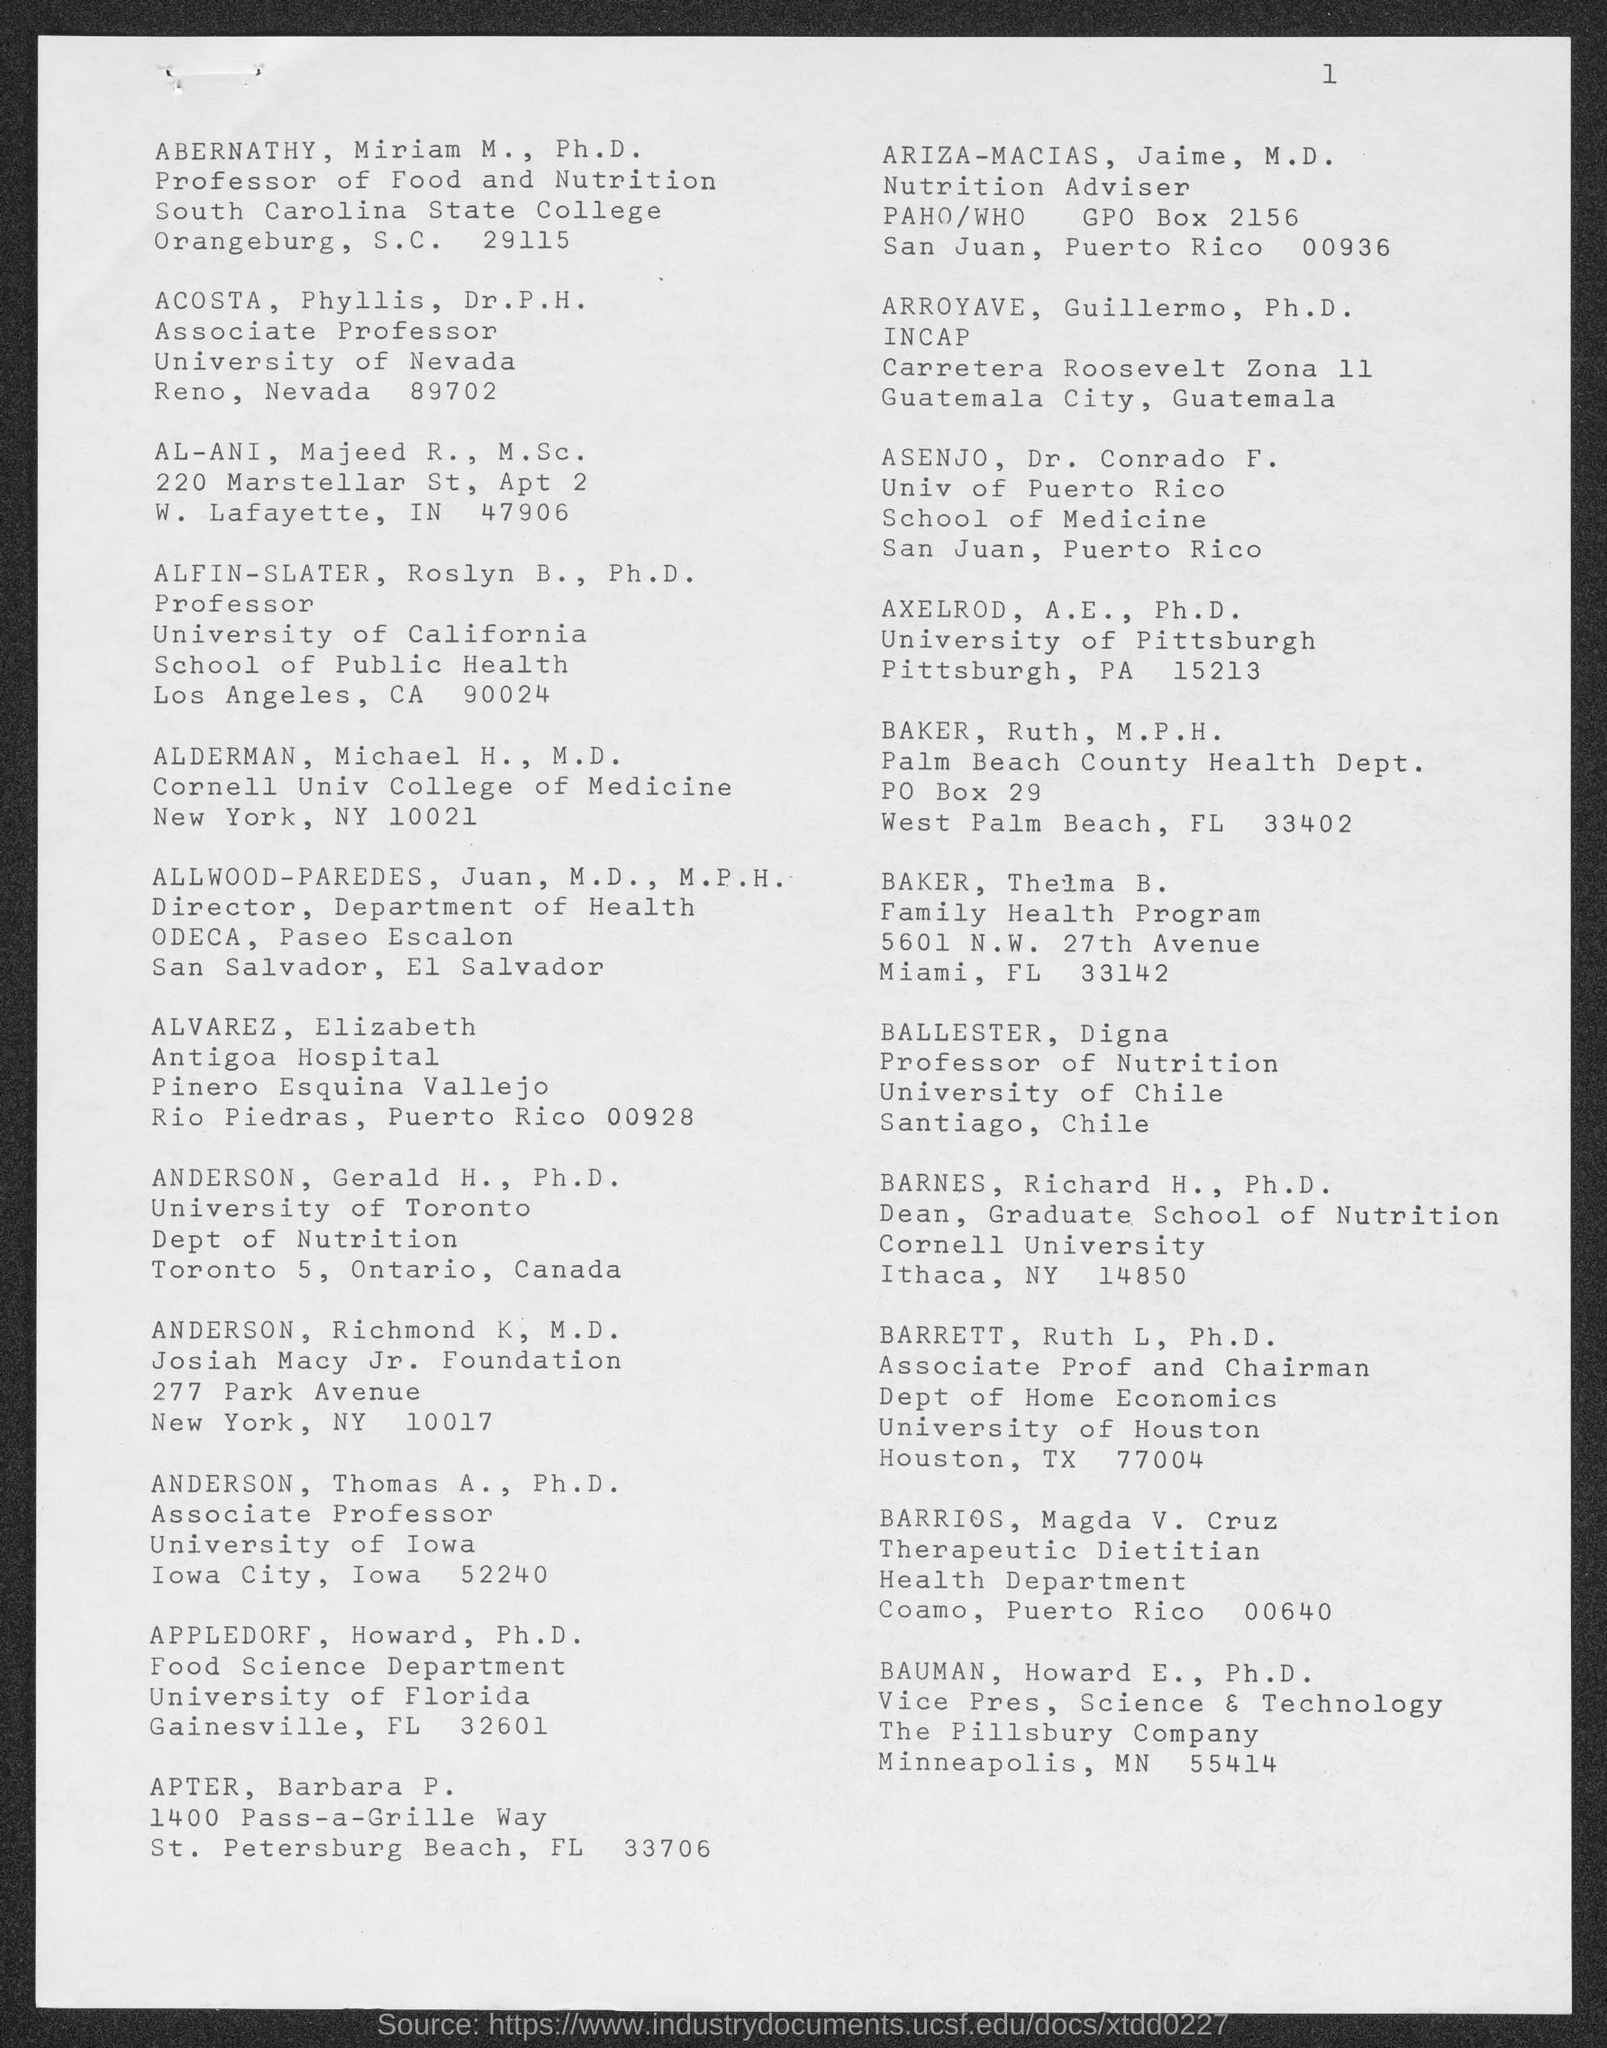Mention a couple of crucial points in this snapshot. Ruth Baker, an individual with a Master of Public Health (M.P.H.) degree, is a part of the Palm Beach County Health Department. The page number on this document is 1. Dr. ALFIN-SLATER, Ph.D. is affiliated with the University of California. Phyllis Acosta is an associate professor who holds the designation of Dr. P. H. The vice president of Science and Technology at The Pillsbury Company is Dr. Howard E. Bauman, who holds a Ph.D. 